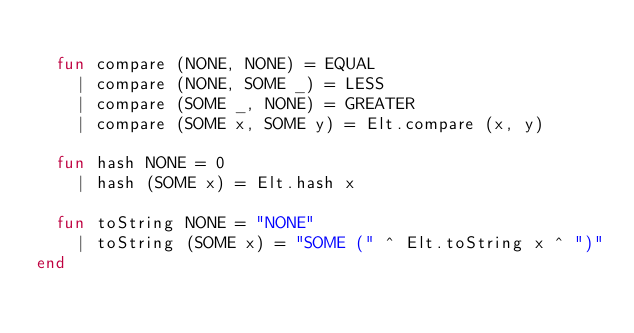Convert code to text. <code><loc_0><loc_0><loc_500><loc_500><_SML_>
  fun compare (NONE, NONE) = EQUAL
    | compare (NONE, SOME _) = LESS
    | compare (SOME _, NONE) = GREATER
    | compare (SOME x, SOME y) = Elt.compare (x, y)

  fun hash NONE = 0
    | hash (SOME x) = Elt.hash x

  fun toString NONE = "NONE"
    | toString (SOME x) = "SOME (" ^ Elt.toString x ^ ")"
end
</code> 